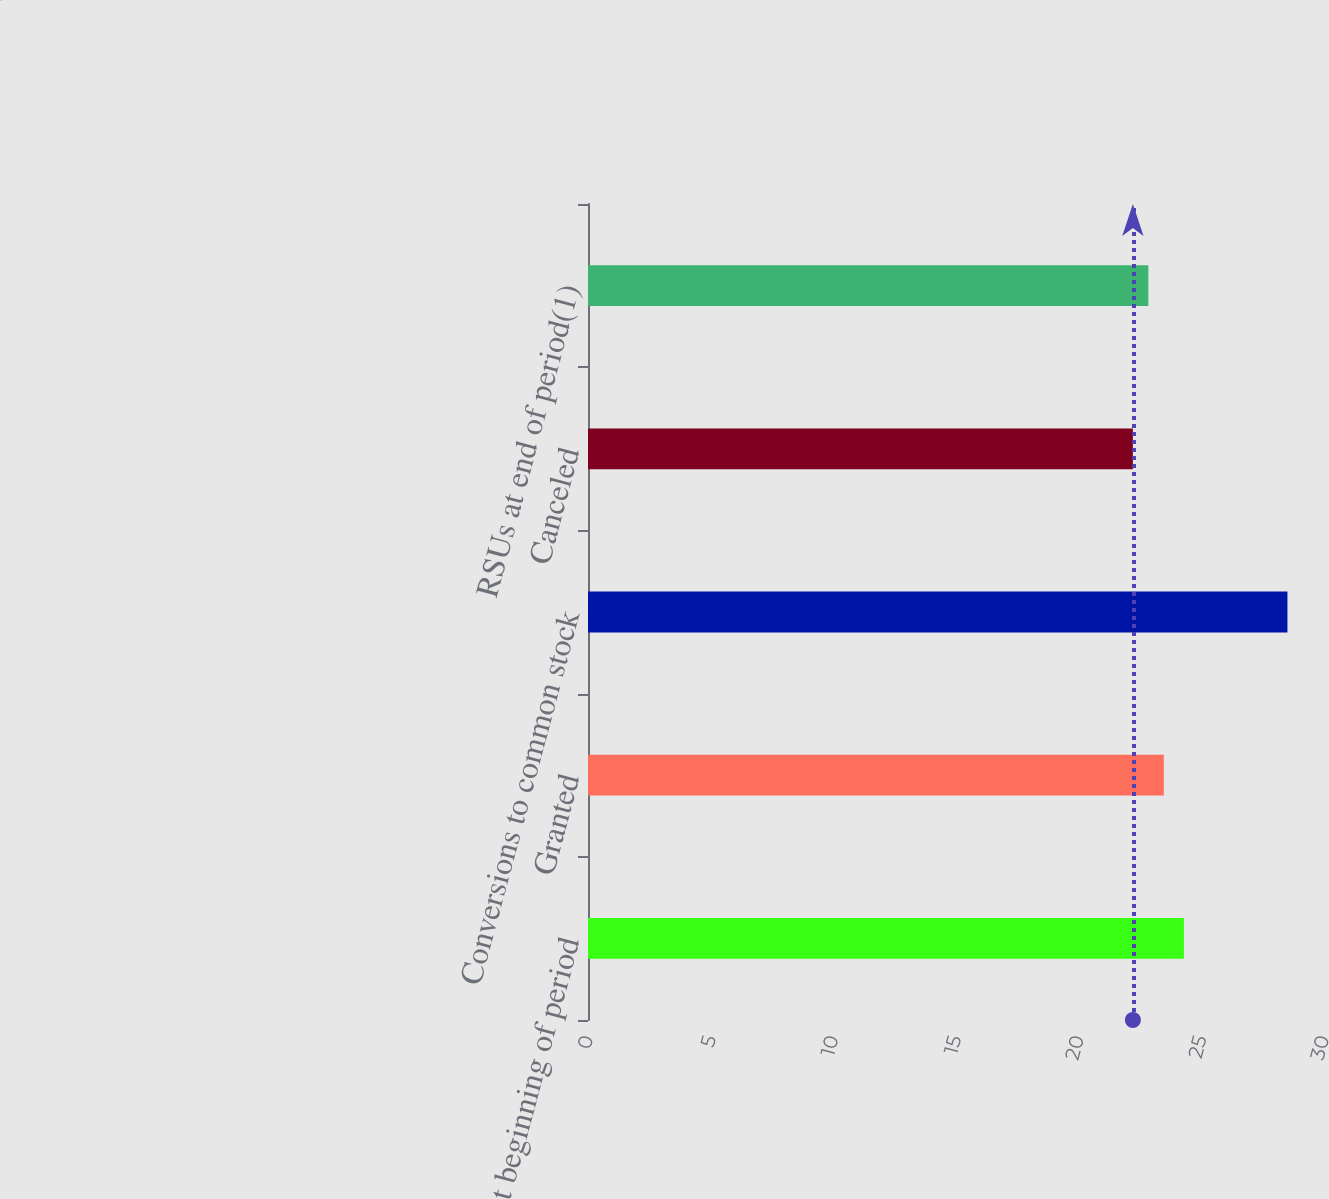Convert chart to OTSL. <chart><loc_0><loc_0><loc_500><loc_500><bar_chart><fcel>RSUs at beginning of period<fcel>Granted<fcel>Conversions to common stock<fcel>Canceled<fcel>RSUs at end of period(1)<nl><fcel>24.29<fcel>23.47<fcel>28.51<fcel>22.21<fcel>22.84<nl></chart> 